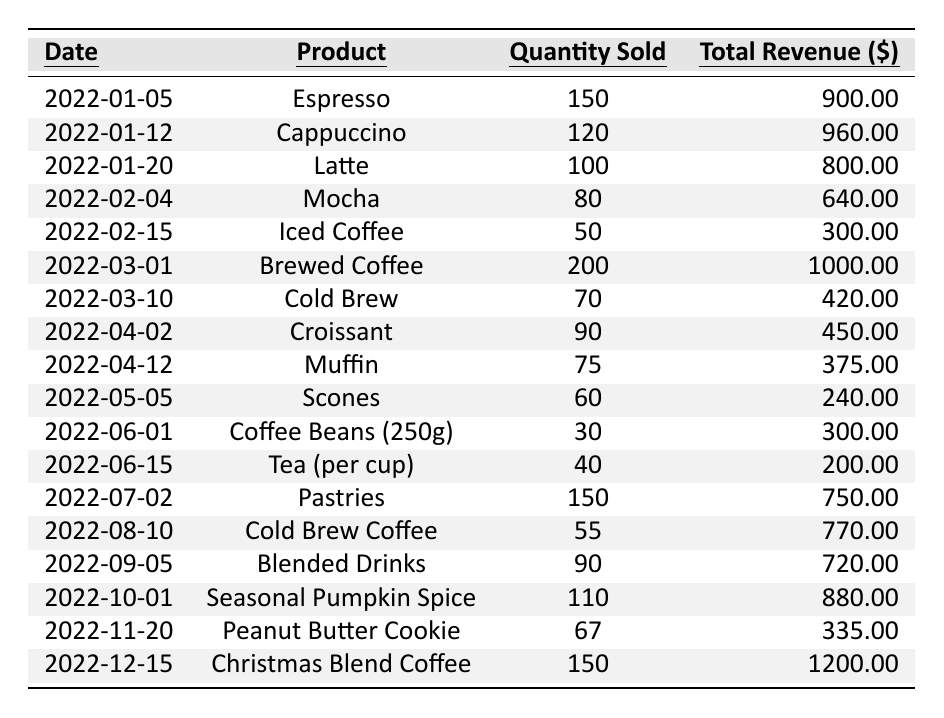What was the total revenue from Espresso sales? The total revenue from Espresso sales is listed in the table under total revenue for the date 2022-01-05. It shows a revenue of 900.00.
Answer: 900.00 Which product sold the most quantity in January 2022? In January 2022, the products sold were Espresso (150), Cappuccino (120), and Latte (100). The highest quantity sold is Espresso with 150 units.
Answer: Espresso What is the average quantity sold across all products in the fiscal year 2022? To calculate the average, first sum the quantities sold: (150 + 120 + 100 + 80 + 50 + 200 + 70 + 90 + 75 + 60 + 30 + 40 + 150 + 55 + 90 + 110 + 67 + 150) = 1,797. There are 17 data points, so the average is 1,797 / 17 ≈ 105.7.
Answer: 105.7 Did the revenue from Christmas Blend Coffee exceed $1,000? The revenue for Christmas Blend Coffee on 2022-12-15 is listed as 1200.00, which is greater than 1000. Hence, the statement is true.
Answer: Yes What was the total revenue generated from pastries sales in 2022? The pastries sold included items like Croissant (450.00), Muffin (375.00), and Pastries (750.00). The total revenue from these is calculated by adding these values: 450.00 + 375.00 + 750.00 = 1575.00.
Answer: 1575.00 How much more revenue was generated from Brewed Coffee than Iced Coffee? The total revenue for Brewed Coffee is 1000.00 and for Iced Coffee, it is 300.00. The difference is 1000.00 - 300.00 = 700.00.
Answer: 700.00 Which product had the lowest sales quantity in February 2022? In February, the products were Mocha (80) and Iced Coffee (50). The product with the lowest quantity sold between these two is Iced Coffee with 50 units sold.
Answer: Iced Coffee What percentage of the total revenue came from the sales of Croissant? The total revenue from Croissant is 450.00. The overall total revenue from all sales (sum of all revenue in the table) is 10,065.00. The percentage is calculated as (450.00 / 10065.00) * 100 ≈ 4.47%.
Answer: 4.47% How many total cups of coffee (Espresso, Cappuccino, Latte, Mocha, Iced Coffee, Brewed Coffee, Cold Brew, Cold Brew Coffee) were sold in 2022? Adding the quantities sold for all coffee types gives: 150 + 120 + 100 + 80 + 50 + 200 + 70 + 55 = 825 cups.
Answer: 825 Was there any month where the sales of Seasonal Pumpkin Spice overtook the sales of all other products? The sales of Seasonal Pumpkin Spice in October were 110, and the highest-selling products that month were Blended Drinks (90) and Pastries (150), which are greater than 110. Therefore, it did not overtake all other products.
Answer: No 